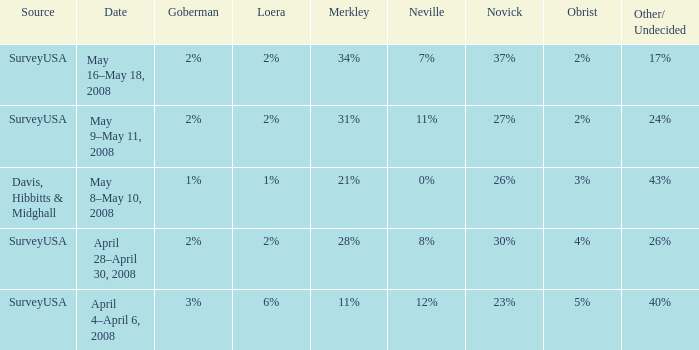Which Neville has a Novick of 23%? 12%. 